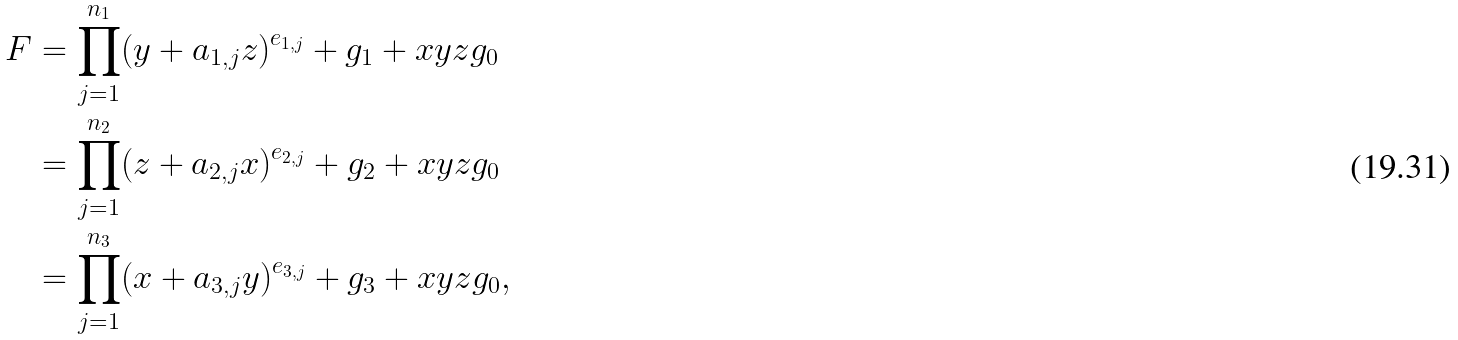<formula> <loc_0><loc_0><loc_500><loc_500>F & = \prod _ { j = 1 } ^ { n _ { 1 } } ( y + a _ { 1 , j } z ) ^ { e _ { 1 , j } } + g _ { 1 } + x y z g _ { 0 } \\ & = \prod _ { j = 1 } ^ { n _ { 2 } } ( z + a _ { 2 , j } x ) ^ { e _ { 2 , j } } + g _ { 2 } + x y z g _ { 0 } \\ & = \prod _ { j = 1 } ^ { n _ { 3 } } ( x + a _ { 3 , j } y ) ^ { e _ { 3 , j } } + g _ { 3 } + x y z g _ { 0 } ,</formula> 